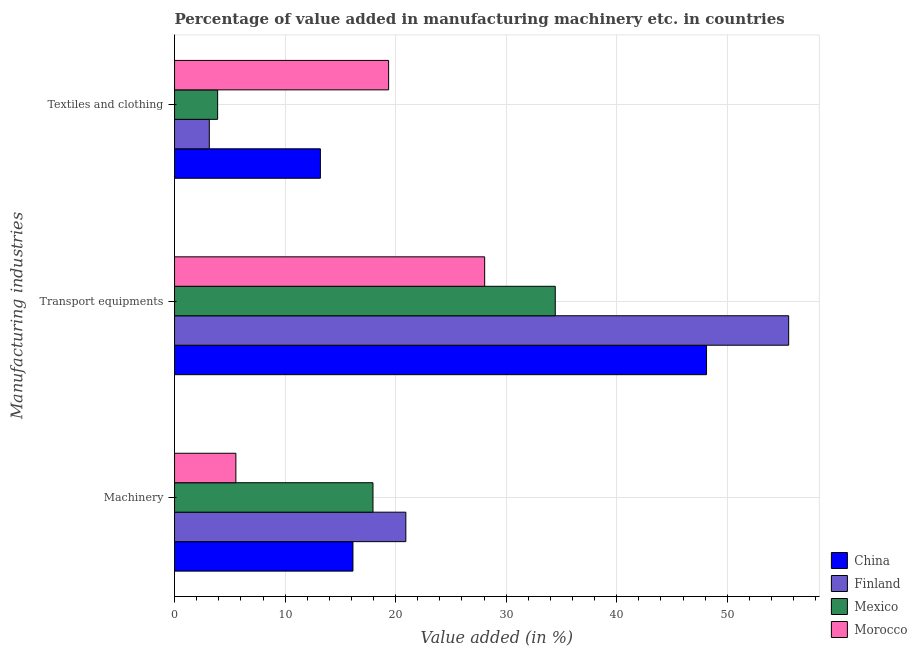How many groups of bars are there?
Your answer should be compact. 3. Are the number of bars per tick equal to the number of legend labels?
Ensure brevity in your answer.  Yes. What is the label of the 2nd group of bars from the top?
Provide a short and direct response. Transport equipments. What is the value added in manufacturing textile and clothing in Finland?
Keep it short and to the point. 3.14. Across all countries, what is the maximum value added in manufacturing transport equipments?
Provide a succinct answer. 55.55. Across all countries, what is the minimum value added in manufacturing machinery?
Ensure brevity in your answer.  5.55. In which country was the value added in manufacturing machinery minimum?
Ensure brevity in your answer.  Morocco. What is the total value added in manufacturing transport equipments in the graph?
Make the answer very short. 166.16. What is the difference between the value added in manufacturing textile and clothing in Mexico and that in Finland?
Make the answer very short. 0.75. What is the difference between the value added in manufacturing transport equipments in Mexico and the value added in manufacturing machinery in Morocco?
Your answer should be compact. 28.89. What is the average value added in manufacturing textile and clothing per country?
Provide a succinct answer. 9.9. What is the difference between the value added in manufacturing textile and clothing and value added in manufacturing transport equipments in Finland?
Provide a succinct answer. -52.41. What is the ratio of the value added in manufacturing transport equipments in Finland to that in Mexico?
Give a very brief answer. 1.61. What is the difference between the highest and the second highest value added in manufacturing transport equipments?
Give a very brief answer. 7.43. What is the difference between the highest and the lowest value added in manufacturing transport equipments?
Provide a short and direct response. 27.5. In how many countries, is the value added in manufacturing textile and clothing greater than the average value added in manufacturing textile and clothing taken over all countries?
Keep it short and to the point. 2. What does the 4th bar from the top in Textiles and clothing represents?
Your response must be concise. China. What does the 1st bar from the bottom in Transport equipments represents?
Offer a terse response. China. How many countries are there in the graph?
Make the answer very short. 4. Are the values on the major ticks of X-axis written in scientific E-notation?
Keep it short and to the point. No. Does the graph contain any zero values?
Give a very brief answer. No. Does the graph contain grids?
Offer a terse response. Yes. Where does the legend appear in the graph?
Make the answer very short. Bottom right. What is the title of the graph?
Provide a short and direct response. Percentage of value added in manufacturing machinery etc. in countries. Does "Arab World" appear as one of the legend labels in the graph?
Make the answer very short. No. What is the label or title of the X-axis?
Offer a terse response. Value added (in %). What is the label or title of the Y-axis?
Ensure brevity in your answer.  Manufacturing industries. What is the Value added (in %) in China in Machinery?
Offer a terse response. 16.14. What is the Value added (in %) of Finland in Machinery?
Offer a terse response. 20.92. What is the Value added (in %) in Mexico in Machinery?
Provide a succinct answer. 17.95. What is the Value added (in %) of Morocco in Machinery?
Give a very brief answer. 5.55. What is the Value added (in %) in China in Transport equipments?
Keep it short and to the point. 48.12. What is the Value added (in %) of Finland in Transport equipments?
Your response must be concise. 55.55. What is the Value added (in %) in Mexico in Transport equipments?
Ensure brevity in your answer.  34.44. What is the Value added (in %) of Morocco in Transport equipments?
Ensure brevity in your answer.  28.05. What is the Value added (in %) of China in Textiles and clothing?
Offer a terse response. 13.19. What is the Value added (in %) in Finland in Textiles and clothing?
Offer a very short reply. 3.14. What is the Value added (in %) of Mexico in Textiles and clothing?
Offer a terse response. 3.9. What is the Value added (in %) of Morocco in Textiles and clothing?
Make the answer very short. 19.36. Across all Manufacturing industries, what is the maximum Value added (in %) in China?
Your answer should be very brief. 48.12. Across all Manufacturing industries, what is the maximum Value added (in %) in Finland?
Keep it short and to the point. 55.55. Across all Manufacturing industries, what is the maximum Value added (in %) of Mexico?
Your answer should be very brief. 34.44. Across all Manufacturing industries, what is the maximum Value added (in %) in Morocco?
Offer a very short reply. 28.05. Across all Manufacturing industries, what is the minimum Value added (in %) of China?
Give a very brief answer. 13.19. Across all Manufacturing industries, what is the minimum Value added (in %) in Finland?
Ensure brevity in your answer.  3.14. Across all Manufacturing industries, what is the minimum Value added (in %) of Mexico?
Offer a terse response. 3.9. Across all Manufacturing industries, what is the minimum Value added (in %) in Morocco?
Give a very brief answer. 5.55. What is the total Value added (in %) in China in the graph?
Provide a succinct answer. 77.45. What is the total Value added (in %) in Finland in the graph?
Your answer should be compact. 79.62. What is the total Value added (in %) in Mexico in the graph?
Give a very brief answer. 56.28. What is the total Value added (in %) in Morocco in the graph?
Your answer should be very brief. 52.96. What is the difference between the Value added (in %) in China in Machinery and that in Transport equipments?
Provide a short and direct response. -31.98. What is the difference between the Value added (in %) in Finland in Machinery and that in Transport equipments?
Ensure brevity in your answer.  -34.63. What is the difference between the Value added (in %) in Mexico in Machinery and that in Transport equipments?
Offer a very short reply. -16.49. What is the difference between the Value added (in %) of Morocco in Machinery and that in Transport equipments?
Make the answer very short. -22.5. What is the difference between the Value added (in %) of China in Machinery and that in Textiles and clothing?
Offer a very short reply. 2.95. What is the difference between the Value added (in %) of Finland in Machinery and that in Textiles and clothing?
Offer a very short reply. 17.78. What is the difference between the Value added (in %) of Mexico in Machinery and that in Textiles and clothing?
Provide a short and direct response. 14.05. What is the difference between the Value added (in %) in Morocco in Machinery and that in Textiles and clothing?
Your response must be concise. -13.82. What is the difference between the Value added (in %) in China in Transport equipments and that in Textiles and clothing?
Make the answer very short. 34.93. What is the difference between the Value added (in %) of Finland in Transport equipments and that in Textiles and clothing?
Give a very brief answer. 52.41. What is the difference between the Value added (in %) of Mexico in Transport equipments and that in Textiles and clothing?
Ensure brevity in your answer.  30.54. What is the difference between the Value added (in %) in Morocco in Transport equipments and that in Textiles and clothing?
Your answer should be compact. 8.69. What is the difference between the Value added (in %) of China in Machinery and the Value added (in %) of Finland in Transport equipments?
Keep it short and to the point. -39.41. What is the difference between the Value added (in %) of China in Machinery and the Value added (in %) of Mexico in Transport equipments?
Ensure brevity in your answer.  -18.3. What is the difference between the Value added (in %) of China in Machinery and the Value added (in %) of Morocco in Transport equipments?
Your answer should be compact. -11.91. What is the difference between the Value added (in %) in Finland in Machinery and the Value added (in %) in Mexico in Transport equipments?
Offer a terse response. -13.52. What is the difference between the Value added (in %) of Finland in Machinery and the Value added (in %) of Morocco in Transport equipments?
Make the answer very short. -7.13. What is the difference between the Value added (in %) of Mexico in Machinery and the Value added (in %) of Morocco in Transport equipments?
Your response must be concise. -10.1. What is the difference between the Value added (in %) of China in Machinery and the Value added (in %) of Finland in Textiles and clothing?
Your answer should be compact. 12.99. What is the difference between the Value added (in %) in China in Machinery and the Value added (in %) in Mexico in Textiles and clothing?
Your answer should be very brief. 12.24. What is the difference between the Value added (in %) in China in Machinery and the Value added (in %) in Morocco in Textiles and clothing?
Give a very brief answer. -3.23. What is the difference between the Value added (in %) in Finland in Machinery and the Value added (in %) in Mexico in Textiles and clothing?
Give a very brief answer. 17.02. What is the difference between the Value added (in %) of Finland in Machinery and the Value added (in %) of Morocco in Textiles and clothing?
Make the answer very short. 1.56. What is the difference between the Value added (in %) in Mexico in Machinery and the Value added (in %) in Morocco in Textiles and clothing?
Your answer should be compact. -1.41. What is the difference between the Value added (in %) in China in Transport equipments and the Value added (in %) in Finland in Textiles and clothing?
Provide a short and direct response. 44.98. What is the difference between the Value added (in %) of China in Transport equipments and the Value added (in %) of Mexico in Textiles and clothing?
Ensure brevity in your answer.  44.22. What is the difference between the Value added (in %) in China in Transport equipments and the Value added (in %) in Morocco in Textiles and clothing?
Provide a short and direct response. 28.76. What is the difference between the Value added (in %) of Finland in Transport equipments and the Value added (in %) of Mexico in Textiles and clothing?
Your answer should be very brief. 51.65. What is the difference between the Value added (in %) in Finland in Transport equipments and the Value added (in %) in Morocco in Textiles and clothing?
Your answer should be compact. 36.19. What is the difference between the Value added (in %) of Mexico in Transport equipments and the Value added (in %) of Morocco in Textiles and clothing?
Ensure brevity in your answer.  15.07. What is the average Value added (in %) in China per Manufacturing industries?
Your answer should be compact. 25.82. What is the average Value added (in %) in Finland per Manufacturing industries?
Your response must be concise. 26.54. What is the average Value added (in %) in Mexico per Manufacturing industries?
Offer a terse response. 18.76. What is the average Value added (in %) in Morocco per Manufacturing industries?
Keep it short and to the point. 17.65. What is the difference between the Value added (in %) in China and Value added (in %) in Finland in Machinery?
Ensure brevity in your answer.  -4.78. What is the difference between the Value added (in %) in China and Value added (in %) in Mexico in Machinery?
Ensure brevity in your answer.  -1.81. What is the difference between the Value added (in %) in China and Value added (in %) in Morocco in Machinery?
Provide a succinct answer. 10.59. What is the difference between the Value added (in %) of Finland and Value added (in %) of Mexico in Machinery?
Your response must be concise. 2.97. What is the difference between the Value added (in %) of Finland and Value added (in %) of Morocco in Machinery?
Offer a terse response. 15.37. What is the difference between the Value added (in %) in Mexico and Value added (in %) in Morocco in Machinery?
Your answer should be compact. 12.4. What is the difference between the Value added (in %) of China and Value added (in %) of Finland in Transport equipments?
Keep it short and to the point. -7.43. What is the difference between the Value added (in %) of China and Value added (in %) of Mexico in Transport equipments?
Offer a very short reply. 13.68. What is the difference between the Value added (in %) of China and Value added (in %) of Morocco in Transport equipments?
Keep it short and to the point. 20.07. What is the difference between the Value added (in %) of Finland and Value added (in %) of Mexico in Transport equipments?
Your response must be concise. 21.11. What is the difference between the Value added (in %) of Finland and Value added (in %) of Morocco in Transport equipments?
Make the answer very short. 27.5. What is the difference between the Value added (in %) of Mexico and Value added (in %) of Morocco in Transport equipments?
Your response must be concise. 6.39. What is the difference between the Value added (in %) of China and Value added (in %) of Finland in Textiles and clothing?
Make the answer very short. 10.05. What is the difference between the Value added (in %) of China and Value added (in %) of Mexico in Textiles and clothing?
Provide a succinct answer. 9.29. What is the difference between the Value added (in %) in China and Value added (in %) in Morocco in Textiles and clothing?
Provide a short and direct response. -6.17. What is the difference between the Value added (in %) of Finland and Value added (in %) of Mexico in Textiles and clothing?
Your answer should be very brief. -0.75. What is the difference between the Value added (in %) of Finland and Value added (in %) of Morocco in Textiles and clothing?
Give a very brief answer. -16.22. What is the difference between the Value added (in %) of Mexico and Value added (in %) of Morocco in Textiles and clothing?
Your response must be concise. -15.47. What is the ratio of the Value added (in %) of China in Machinery to that in Transport equipments?
Give a very brief answer. 0.34. What is the ratio of the Value added (in %) in Finland in Machinery to that in Transport equipments?
Keep it short and to the point. 0.38. What is the ratio of the Value added (in %) in Mexico in Machinery to that in Transport equipments?
Offer a terse response. 0.52. What is the ratio of the Value added (in %) of Morocco in Machinery to that in Transport equipments?
Ensure brevity in your answer.  0.2. What is the ratio of the Value added (in %) of China in Machinery to that in Textiles and clothing?
Ensure brevity in your answer.  1.22. What is the ratio of the Value added (in %) in Finland in Machinery to that in Textiles and clothing?
Your response must be concise. 6.65. What is the ratio of the Value added (in %) in Mexico in Machinery to that in Textiles and clothing?
Your answer should be very brief. 4.61. What is the ratio of the Value added (in %) in Morocco in Machinery to that in Textiles and clothing?
Offer a terse response. 0.29. What is the ratio of the Value added (in %) of China in Transport equipments to that in Textiles and clothing?
Offer a terse response. 3.65. What is the ratio of the Value added (in %) in Finland in Transport equipments to that in Textiles and clothing?
Make the answer very short. 17.66. What is the ratio of the Value added (in %) of Mexico in Transport equipments to that in Textiles and clothing?
Provide a short and direct response. 8.84. What is the ratio of the Value added (in %) in Morocco in Transport equipments to that in Textiles and clothing?
Your answer should be compact. 1.45. What is the difference between the highest and the second highest Value added (in %) in China?
Your answer should be very brief. 31.98. What is the difference between the highest and the second highest Value added (in %) of Finland?
Keep it short and to the point. 34.63. What is the difference between the highest and the second highest Value added (in %) of Mexico?
Provide a succinct answer. 16.49. What is the difference between the highest and the second highest Value added (in %) in Morocco?
Keep it short and to the point. 8.69. What is the difference between the highest and the lowest Value added (in %) of China?
Provide a succinct answer. 34.93. What is the difference between the highest and the lowest Value added (in %) in Finland?
Make the answer very short. 52.41. What is the difference between the highest and the lowest Value added (in %) of Mexico?
Provide a succinct answer. 30.54. What is the difference between the highest and the lowest Value added (in %) of Morocco?
Your answer should be compact. 22.5. 